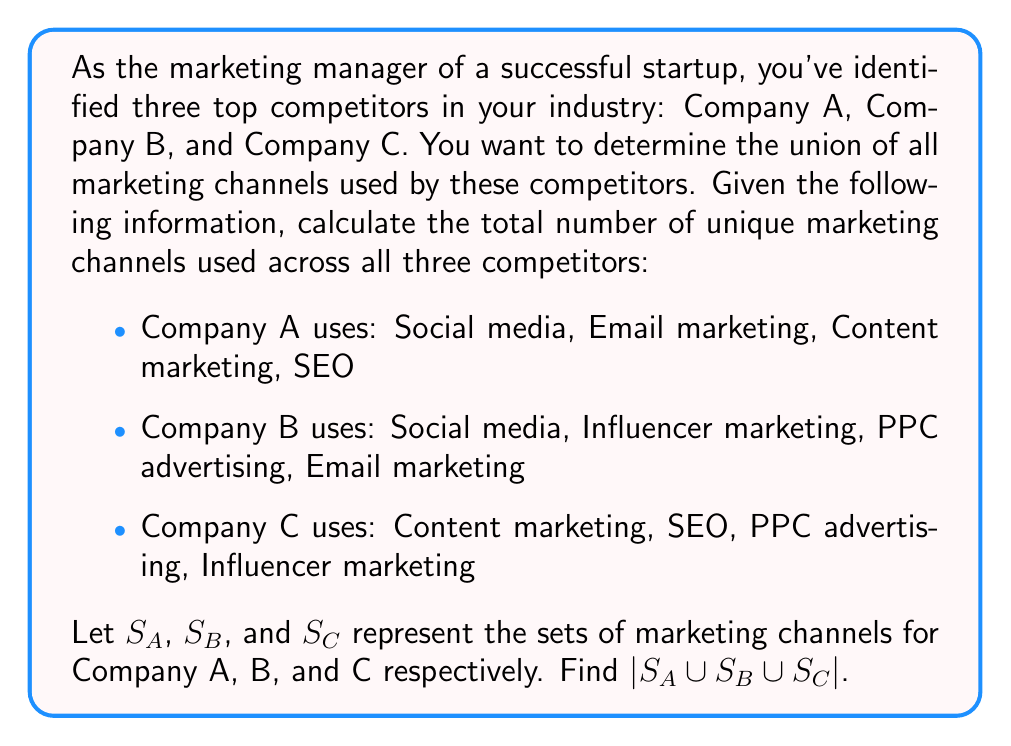Solve this math problem. To solve this problem, we'll use the principle of inclusion-exclusion for three sets:

$$|S_A \cup S_B \cup S_C| = |S_A| + |S_B| + |S_C| - |S_A \cap S_B| - |S_A \cap S_C| - |S_B \cap S_C| + |S_A \cap S_B \cap S_C|$$

Let's break it down step by step:

1. First, let's identify the individual set sizes:
   $|S_A| = 4$, $|S_B| = 4$, $|S_C| = 4$

2. Now, let's find the intersections:
   $S_A \cap S_B = \{\text{Social media, Email marketing}\}$, so $|S_A \cap S_B| = 2$
   $S_A \cap S_C = \{\text{Content marketing, SEO}\}$, so $|S_A \cap S_C| = 2$
   $S_B \cap S_C = \{\text{Influencer marketing, PPC advertising}\}$, so $|S_B \cap S_C| = 2$

3. The intersection of all three sets:
   $S_A \cap S_B \cap S_C = \{\}$, so $|S_A \cap S_B \cap S_C| = 0$

4. Now we can plug these values into our formula:

   $$|S_A \cup S_B \cup S_C| = 4 + 4 + 4 - 2 - 2 - 2 + 0 = 6$$

Therefore, the total number of unique marketing channels used across all three competitors is 6.
Answer: $|S_A \cup S_B \cup S_C| = 6$ 